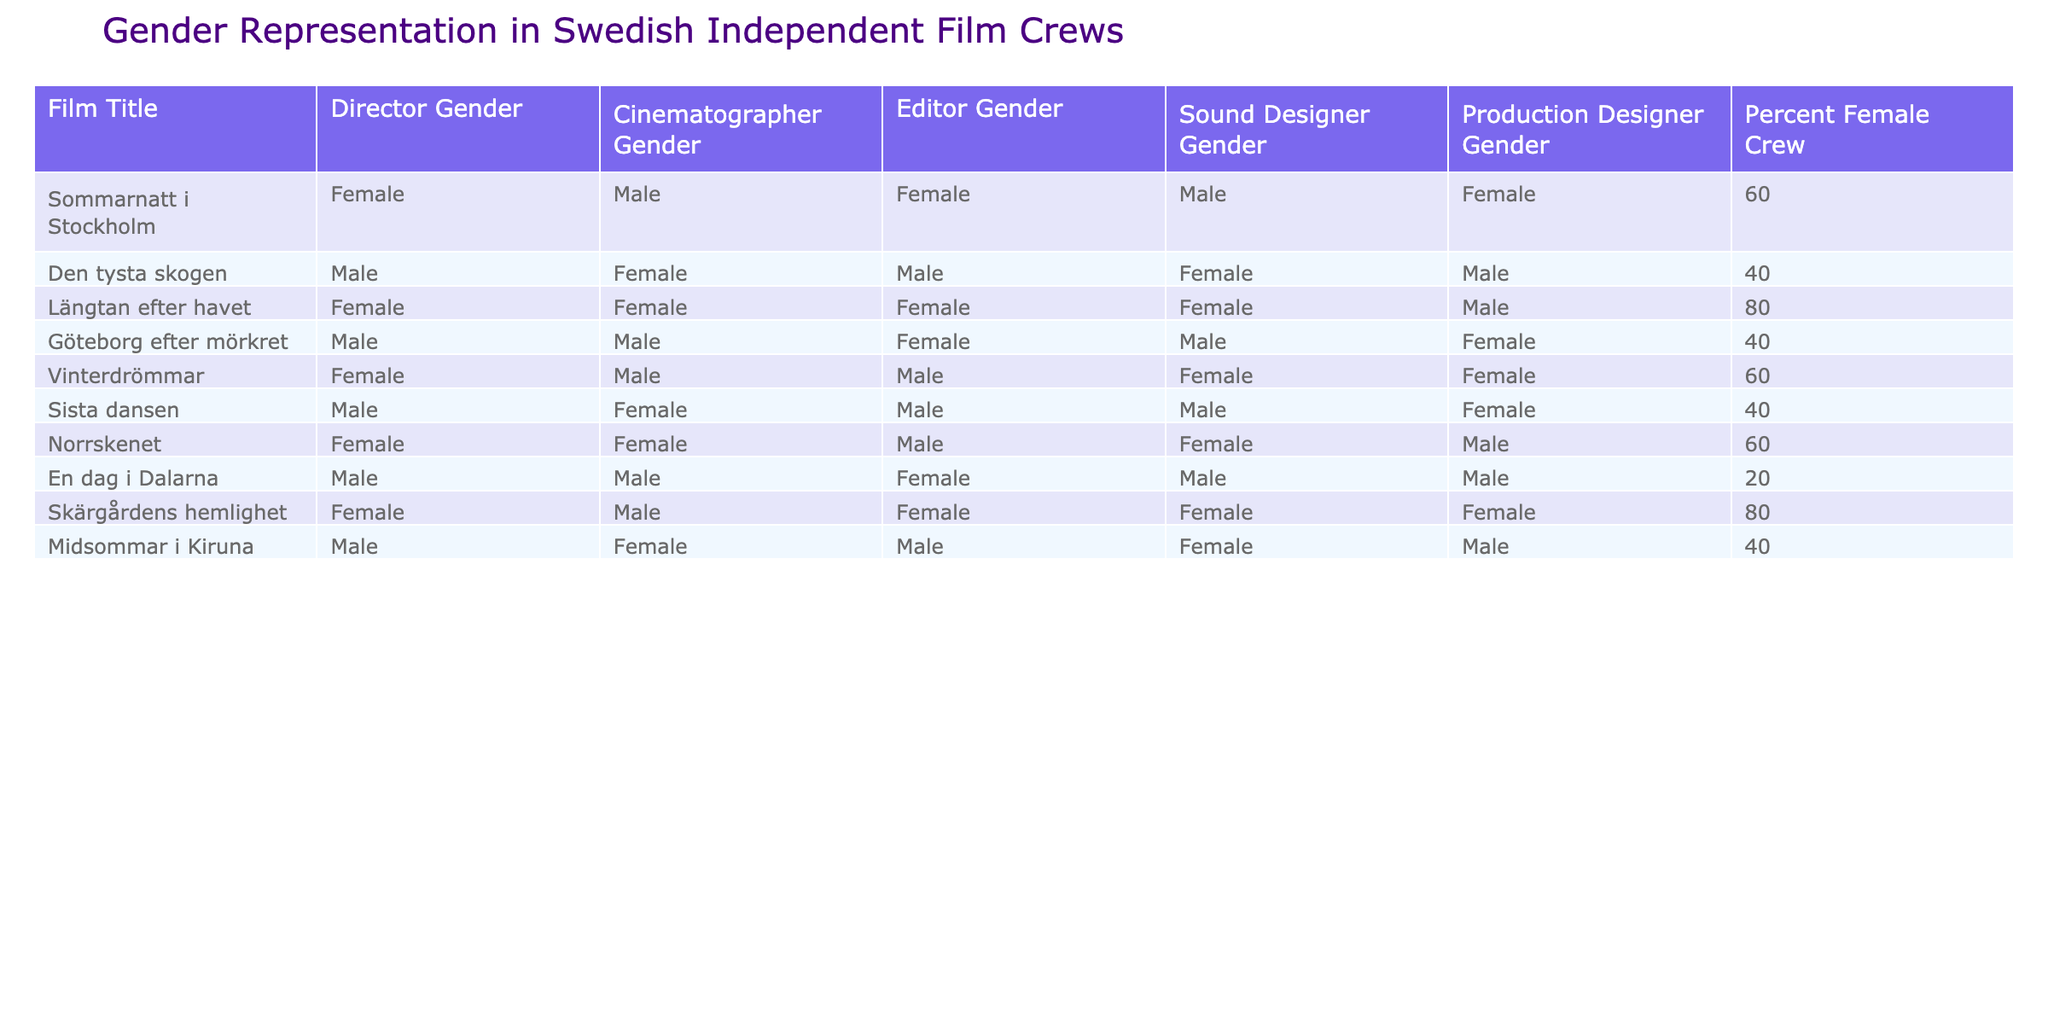What is the film with the highest percentage of female crew members? By looking through the table, "Längtan efter havet" and "Skärgårdens hemlighet" both have the highest percentage of female crew members at 80%.
Answer: "Längtan efter havet" and "Skärgårdens hemlighet" How many films have a female Director? By examining the Director Gender column, there are 5 films listed with a female director out of the 10 total films.
Answer: 5 What is the average percentage of female crew members across all films? To calculate the average, sum the percentages of female crew members: (60 + 40 + 80 + 40 + 60 + 40 + 60 + 20 + 80 + 40) = 520. Then, divide this total by the number of films (10): 520/10 = 52.
Answer: 52 Is there any film with a completely female crew? None of the films listed in the table have a 100% female crew; the percentages range from 20% to 80%.
Answer: No Which film has the lowest representation of female crew members? "En dag i Dalarna" has the lowest representation of female crew members at 20%.
Answer: "En dag i Dalarna" How many films have a female sound designer? Reviewing the Sound Designer Gender column, 4 films have a female sound designer: "Längtan efter havet," "Norrskenet," "Skärgårdens hemlighet," and "Vinterdrömmar."
Answer: 4 What is the difference in the percentage of female crew members between "Den tysta skogen" and "Längtan efter havet"? "Den tysta skogen" has 40% female crew, and "Längtan efter havet" has 80%. The difference is 80 - 40 = 40%.
Answer: 40% Which gender is more frequently represented among directors in this table? By reviewing the Director Gender column, there are 5 male directors and 5 female directors, indicating both genders are equally represented.
Answer: Equal What percentage of films have a male cinematographer? In the Cinematographer Gender column, 6 out of 10 films have a male cinematographer, which gives us a percentage of 60%.
Answer: 60% Which film has both a female director and a female production designer? "Längtan efter havet" has both a female director and a female production designer.
Answer: "Längtan efter havet" 